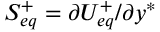<formula> <loc_0><loc_0><loc_500><loc_500>S _ { e q } ^ { + } = \partial U _ { e q } ^ { + } / \partial y ^ { * }</formula> 